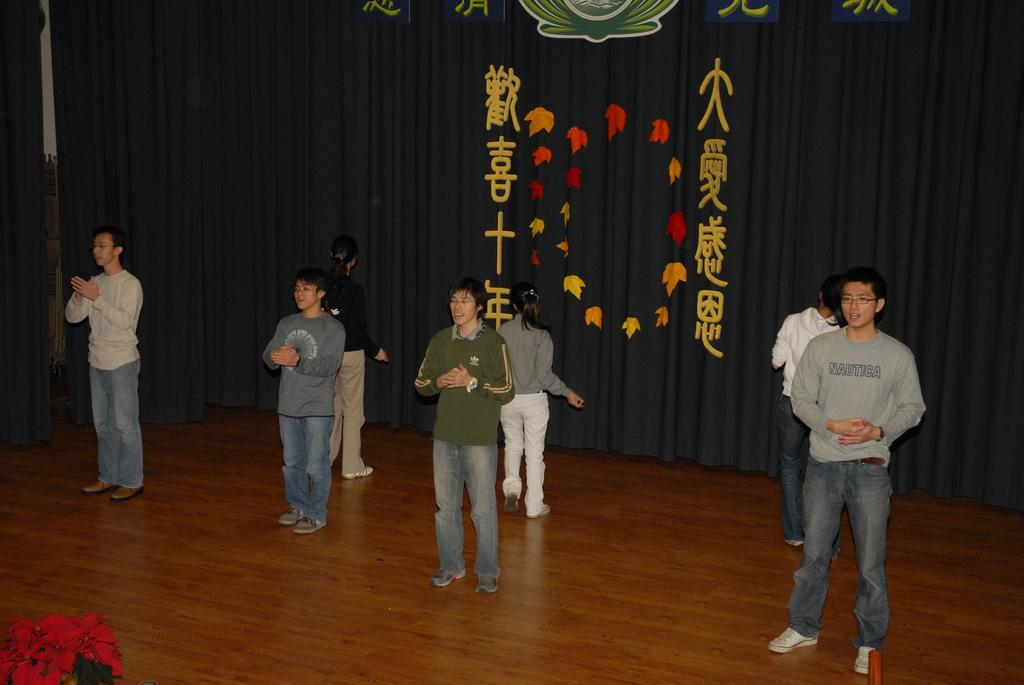What is the main subject of the picture? The main subject of the picture is a boat. Where is the boat located in the image? The boat is on the water. What can be seen in the background of the picture? There are mountains in the background of the picture. What idea is being expressed by the boat in the image? The boat in the image is not expressing any idea; it is simply a boat on the water. Can you tell me how the mountains in the background are feeling in the image? The mountains in the background are not capable of feeling emotions like anger; they are simply a part of the landscape. 